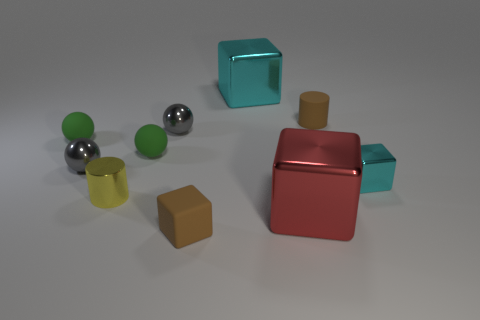Subtract 1 blocks. How many blocks are left? 3 Subtract all cubes. How many objects are left? 6 Subtract 1 gray spheres. How many objects are left? 9 Subtract all yellow rubber cubes. Subtract all rubber cubes. How many objects are left? 9 Add 3 small brown matte cylinders. How many small brown matte cylinders are left? 4 Add 8 tiny purple metallic cubes. How many tiny purple metallic cubes exist? 8 